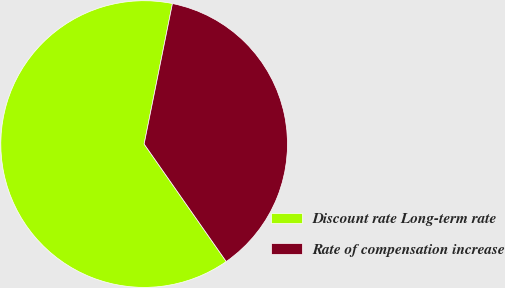Convert chart to OTSL. <chart><loc_0><loc_0><loc_500><loc_500><pie_chart><fcel>Discount rate Long-term rate<fcel>Rate of compensation increase<nl><fcel>62.87%<fcel>37.13%<nl></chart> 